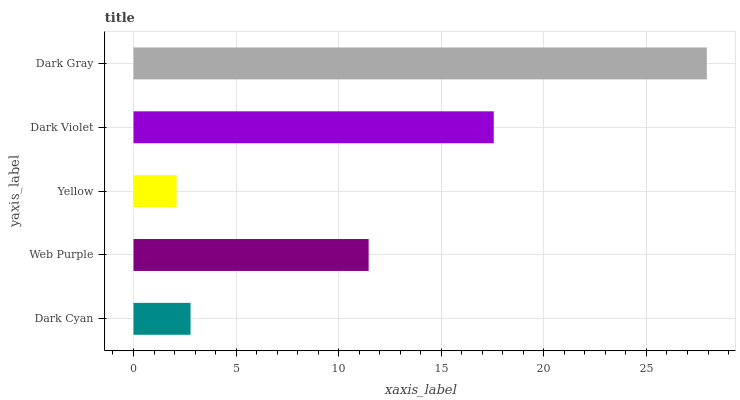Is Yellow the minimum?
Answer yes or no. Yes. Is Dark Gray the maximum?
Answer yes or no. Yes. Is Web Purple the minimum?
Answer yes or no. No. Is Web Purple the maximum?
Answer yes or no. No. Is Web Purple greater than Dark Cyan?
Answer yes or no. Yes. Is Dark Cyan less than Web Purple?
Answer yes or no. Yes. Is Dark Cyan greater than Web Purple?
Answer yes or no. No. Is Web Purple less than Dark Cyan?
Answer yes or no. No. Is Web Purple the high median?
Answer yes or no. Yes. Is Web Purple the low median?
Answer yes or no. Yes. Is Dark Violet the high median?
Answer yes or no. No. Is Dark Violet the low median?
Answer yes or no. No. 